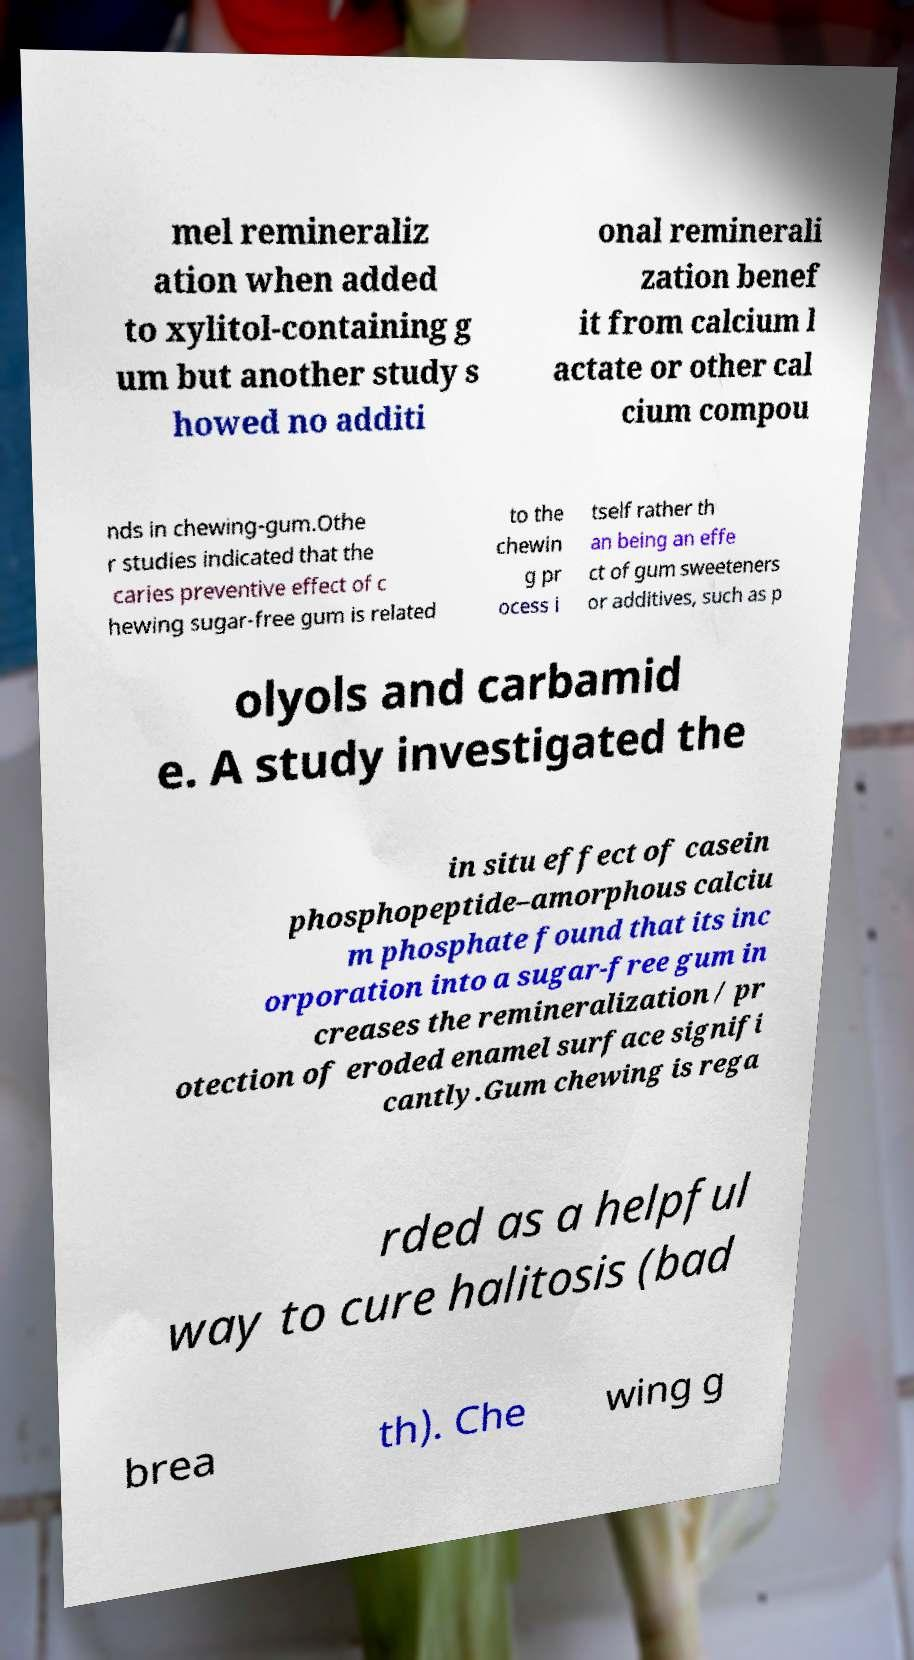Can you accurately transcribe the text from the provided image for me? mel remineraliz ation when added to xylitol-containing g um but another study s howed no additi onal reminerali zation benef it from calcium l actate or other cal cium compou nds in chewing-gum.Othe r studies indicated that the caries preventive effect of c hewing sugar-free gum is related to the chewin g pr ocess i tself rather th an being an effe ct of gum sweeteners or additives, such as p olyols and carbamid e. A study investigated the in situ effect of casein phosphopeptide–amorphous calciu m phosphate found that its inc orporation into a sugar-free gum in creases the remineralization / pr otection of eroded enamel surface signifi cantly.Gum chewing is rega rded as a helpful way to cure halitosis (bad brea th). Che wing g 